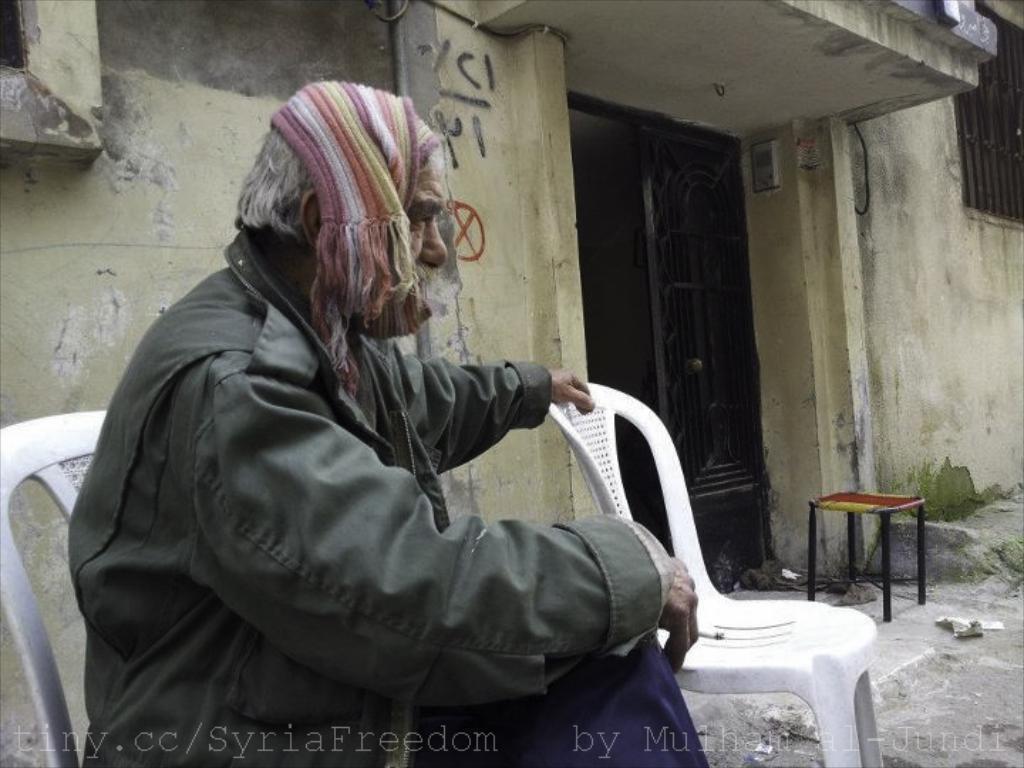Please provide a concise description of this image. On the left a person is sitting on a chair and there is a cigarette in his finger and tied his head with a cloth and placed his one hand on the beside chair. In the background we can see wall,door,window and a stool on the ground. 